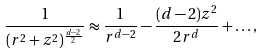<formula> <loc_0><loc_0><loc_500><loc_500>\frac { 1 } { ( r ^ { 2 } + z ^ { 2 } ) ^ { \frac { d - 2 } { 2 } } } \approx \frac { 1 } { r ^ { d - 2 } } - \frac { ( d - 2 ) z ^ { 2 } } { 2 r ^ { d } } + \dots ,</formula> 